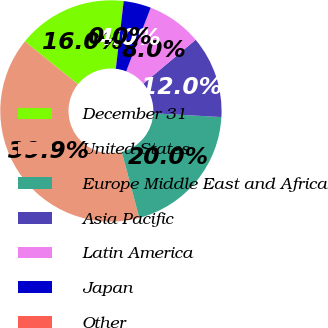Convert chart. <chart><loc_0><loc_0><loc_500><loc_500><pie_chart><fcel>December 31<fcel>United States<fcel>Europe Middle East and Africa<fcel>Asia Pacific<fcel>Latin America<fcel>Japan<fcel>Other<nl><fcel>16.0%<fcel>39.94%<fcel>19.99%<fcel>12.01%<fcel>8.02%<fcel>4.02%<fcel>0.03%<nl></chart> 